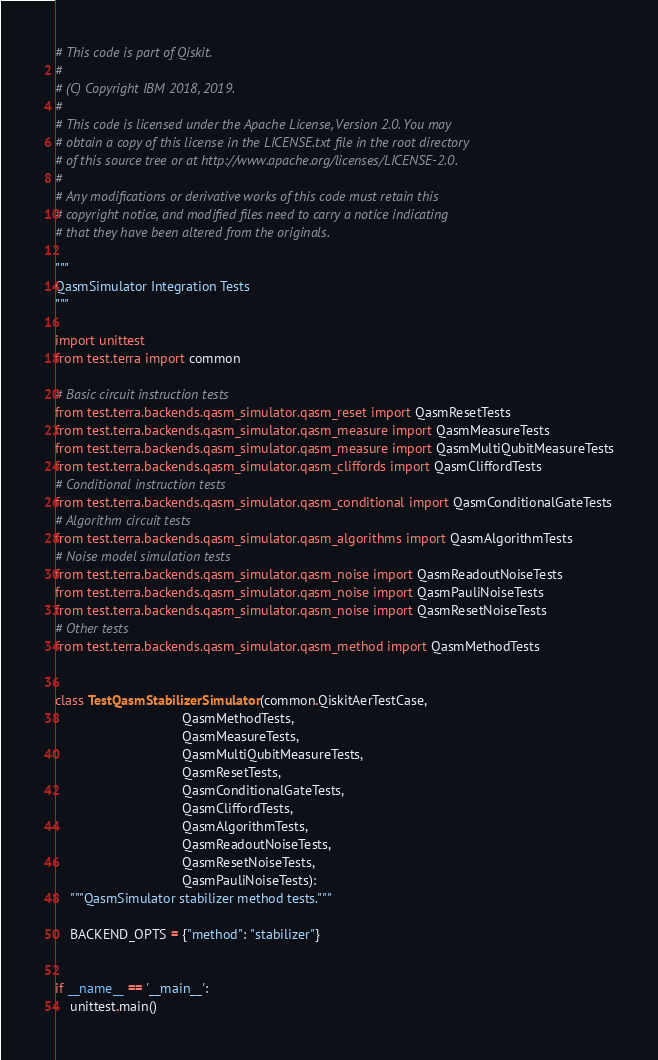Convert code to text. <code><loc_0><loc_0><loc_500><loc_500><_Python_># This code is part of Qiskit.
#
# (C) Copyright IBM 2018, 2019.
#
# This code is licensed under the Apache License, Version 2.0. You may
# obtain a copy of this license in the LICENSE.txt file in the root directory
# of this source tree or at http://www.apache.org/licenses/LICENSE-2.0.
#
# Any modifications or derivative works of this code must retain this
# copyright notice, and modified files need to carry a notice indicating
# that they have been altered from the originals.

"""
QasmSimulator Integration Tests
"""

import unittest
from test.terra import common

# Basic circuit instruction tests
from test.terra.backends.qasm_simulator.qasm_reset import QasmResetTests
from test.terra.backends.qasm_simulator.qasm_measure import QasmMeasureTests
from test.terra.backends.qasm_simulator.qasm_measure import QasmMultiQubitMeasureTests
from test.terra.backends.qasm_simulator.qasm_cliffords import QasmCliffordTests
# Conditional instruction tests
from test.terra.backends.qasm_simulator.qasm_conditional import QasmConditionalGateTests
# Algorithm circuit tests
from test.terra.backends.qasm_simulator.qasm_algorithms import QasmAlgorithmTests
# Noise model simulation tests
from test.terra.backends.qasm_simulator.qasm_noise import QasmReadoutNoiseTests
from test.terra.backends.qasm_simulator.qasm_noise import QasmPauliNoiseTests
from test.terra.backends.qasm_simulator.qasm_noise import QasmResetNoiseTests
# Other tests
from test.terra.backends.qasm_simulator.qasm_method import QasmMethodTests


class TestQasmStabilizerSimulator(common.QiskitAerTestCase,
                                  QasmMethodTests,
                                  QasmMeasureTests,
                                  QasmMultiQubitMeasureTests,
                                  QasmResetTests,
                                  QasmConditionalGateTests,
                                  QasmCliffordTests,
                                  QasmAlgorithmTests,
                                  QasmReadoutNoiseTests,
                                  QasmResetNoiseTests,
                                  QasmPauliNoiseTests):
    """QasmSimulator stabilizer method tests."""

    BACKEND_OPTS = {"method": "stabilizer"}


if __name__ == '__main__':
    unittest.main()
</code> 